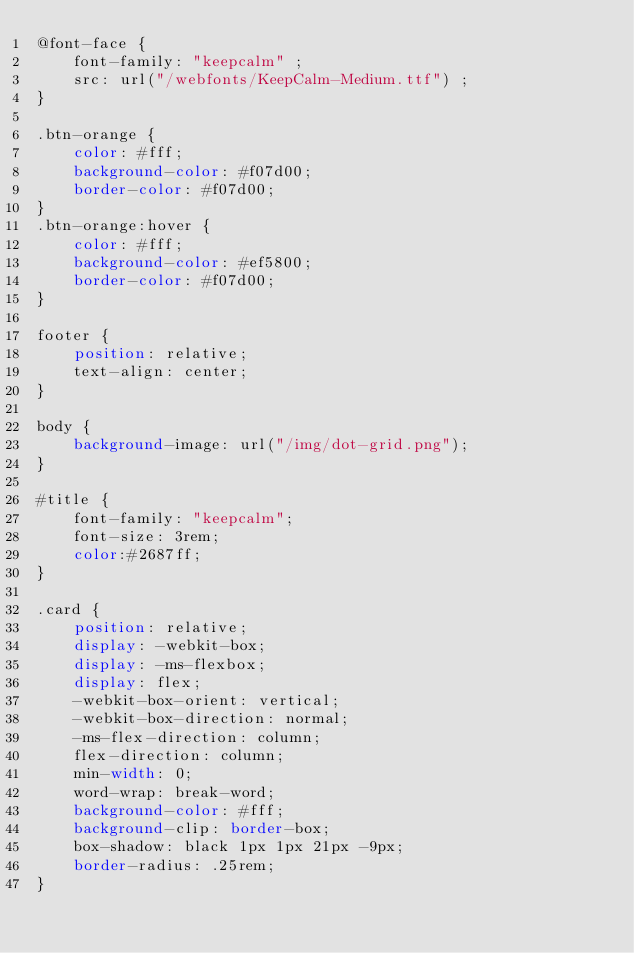<code> <loc_0><loc_0><loc_500><loc_500><_CSS_>@font-face {
	font-family: "keepcalm" ;
	src: url("/webfonts/KeepCalm-Medium.ttf") ;
}

.btn-orange {
	color: #fff;
	background-color: #f07d00;
	border-color: #f07d00;
}
.btn-orange:hover {
	color: #fff;
	background-color: #ef5800;
	border-color: #f07d00;
}

footer {
	position: relative;
	text-align: center;
}

body {
	background-image: url("/img/dot-grid.png");
}

#title {
	font-family: "keepcalm";
    font-size: 3rem;
	color:#2687ff;
}

.card {
    position: relative;
    display: -webkit-box;
    display: -ms-flexbox;
    display: flex;
    -webkit-box-orient: vertical;
    -webkit-box-direction: normal;
    -ms-flex-direction: column;
    flex-direction: column;
    min-width: 0;
    word-wrap: break-word;
    background-color: #fff;
    background-clip: border-box;
    box-shadow: black 1px 1px 21px -9px;
    border-radius: .25rem;
}</code> 